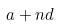<formula> <loc_0><loc_0><loc_500><loc_500>a + n d</formula> 